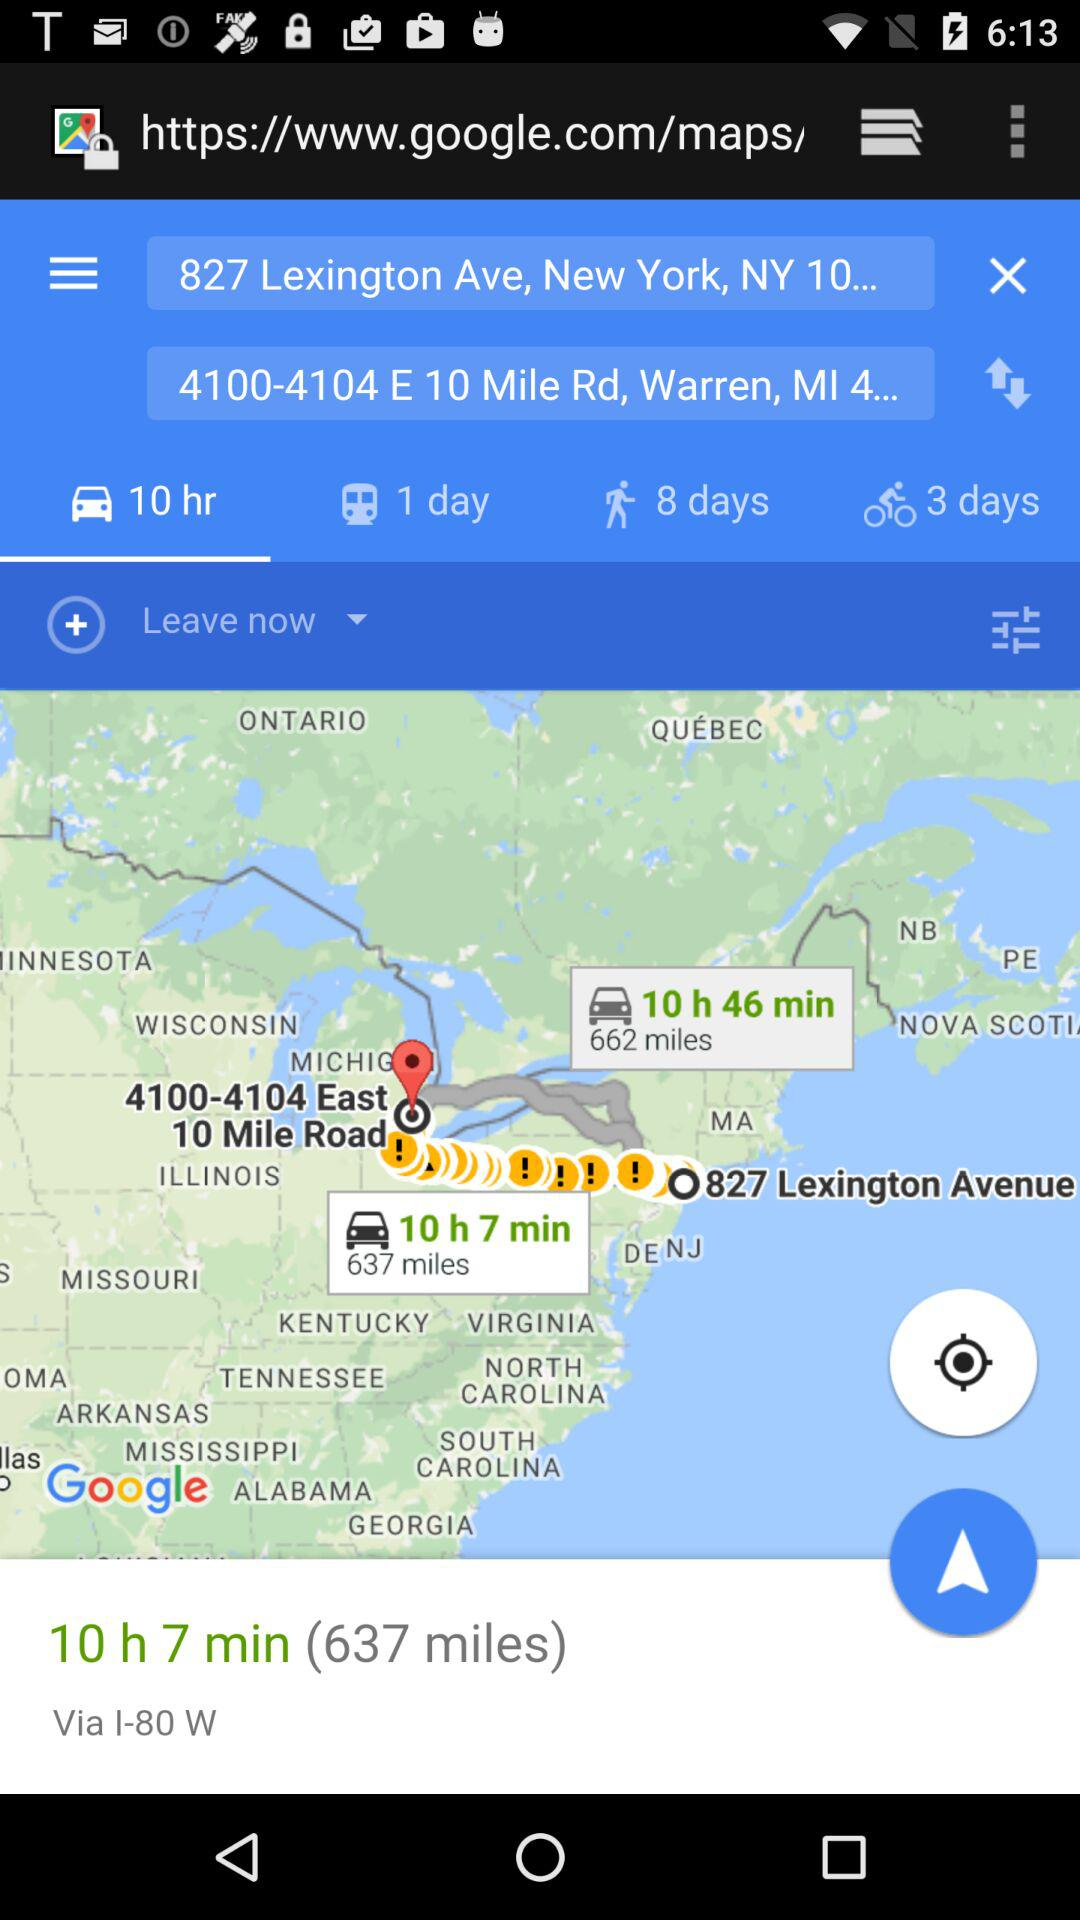How many days does it take to walk between the two locations?
Answer the question using a single word or phrase. 8 days 